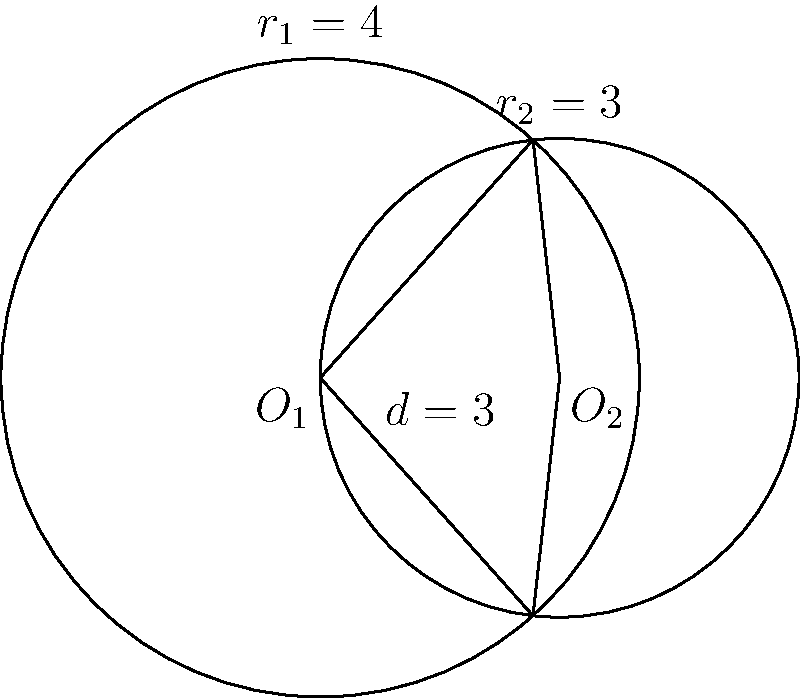Two circular plates, one representing a large vegan pizza with radius $r_1 = 4$ units and another representing a smaller dessert plate with radius $r_2 = 3$ units, are partially overlapping. The centers of the plates are 3 units apart. Calculate the area of the overlapping region to determine how much of the dessert plate is covered by the pizza. To find the area of overlap between two circles, we can use the formula for the area of intersection:

$$A = r_1^2 \arccos(\frac{d^2 + r_1^2 - r_2^2}{2dr_1}) + r_2^2 \arccos(\frac{d^2 + r_2^2 - r_1^2}{2dr_2}) - \frac{1}{2}\sqrt{(-d+r_1+r_2)(d+r_1-r_2)(d-r_1+r_2)(d+r_1+r_2)}$$

Where:
$r_1 = 4$ (radius of the larger circle)
$r_2 = 3$ (radius of the smaller circle)
$d = 3$ (distance between centers)

Step 1: Calculate the first term
$$r_1^2 \arccos(\frac{d^2 + r_1^2 - r_2^2}{2dr_1}) = 16 \arccos(\frac{9 + 16 - 9}{2 \cdot 3 \cdot 4}) = 16 \arccos(\frac{16}{24}) \approx 10.4720$$

Step 2: Calculate the second term
$$r_2^2 \arccos(\frac{d^2 + r_2^2 - r_1^2}{2dr_2}) = 9 \arccos(\frac{9 + 9 - 16}{2 \cdot 3 \cdot 3}) = 9 \arccos(\frac{2}{18}) \approx 13.3645$$

Step 3: Calculate the third term
$$\frac{1}{2}\sqrt{(-d+r_1+r_2)(d+r_1-r_2)(d-r_1+r_2)(d+r_1+r_2)}$$
$$= \frac{1}{2}\sqrt{(-3+4+3)(3+4-3)(3-4+3)(3+4+3)}$$
$$= \frac{1}{2}\sqrt{4 \cdot 4 \cdot 2 \cdot 10} = \frac{1}{2}\sqrt{320} \approx 8.9443$$

Step 4: Combine the terms
$$A = 10.4720 + 13.3645 - 8.9443 \approx 14.8922$$

Therefore, the area of overlap is approximately 14.8922 square units.
Answer: 14.8922 square units 